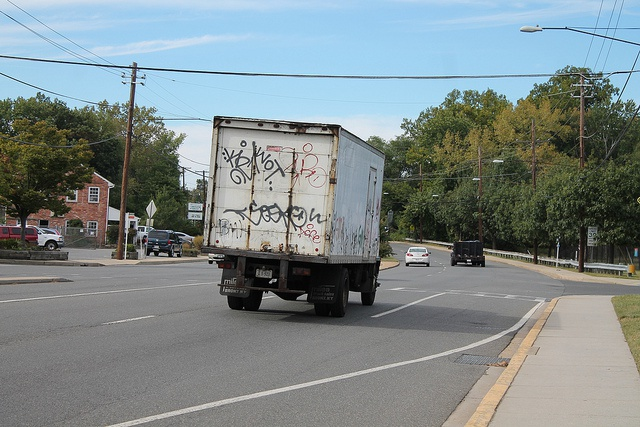Describe the objects in this image and their specific colors. I can see truck in lavender, darkgray, black, gray, and lightgray tones, car in lavender, black, gray, blue, and darkgray tones, truck in lavender, black, gray, and maroon tones, car in lavender, maroon, black, and brown tones, and car in lavender, lightgray, darkgray, black, and gray tones in this image. 